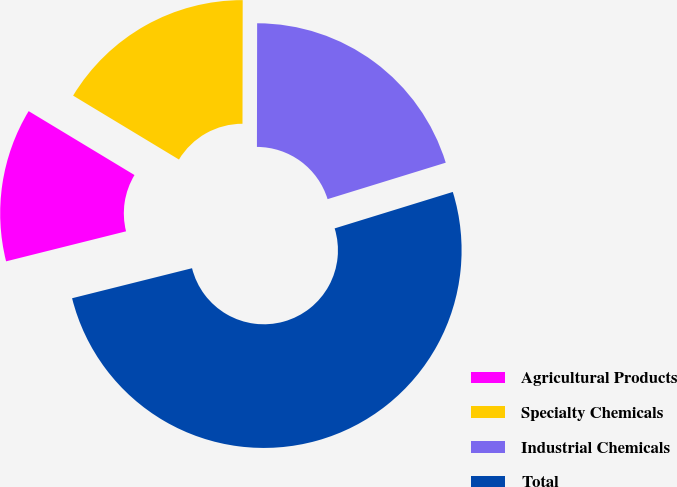Convert chart. <chart><loc_0><loc_0><loc_500><loc_500><pie_chart><fcel>Agricultural Products<fcel>Specialty Chemicals<fcel>Industrial Chemicals<fcel>Total<nl><fcel>12.55%<fcel>16.38%<fcel>20.21%<fcel>50.86%<nl></chart> 